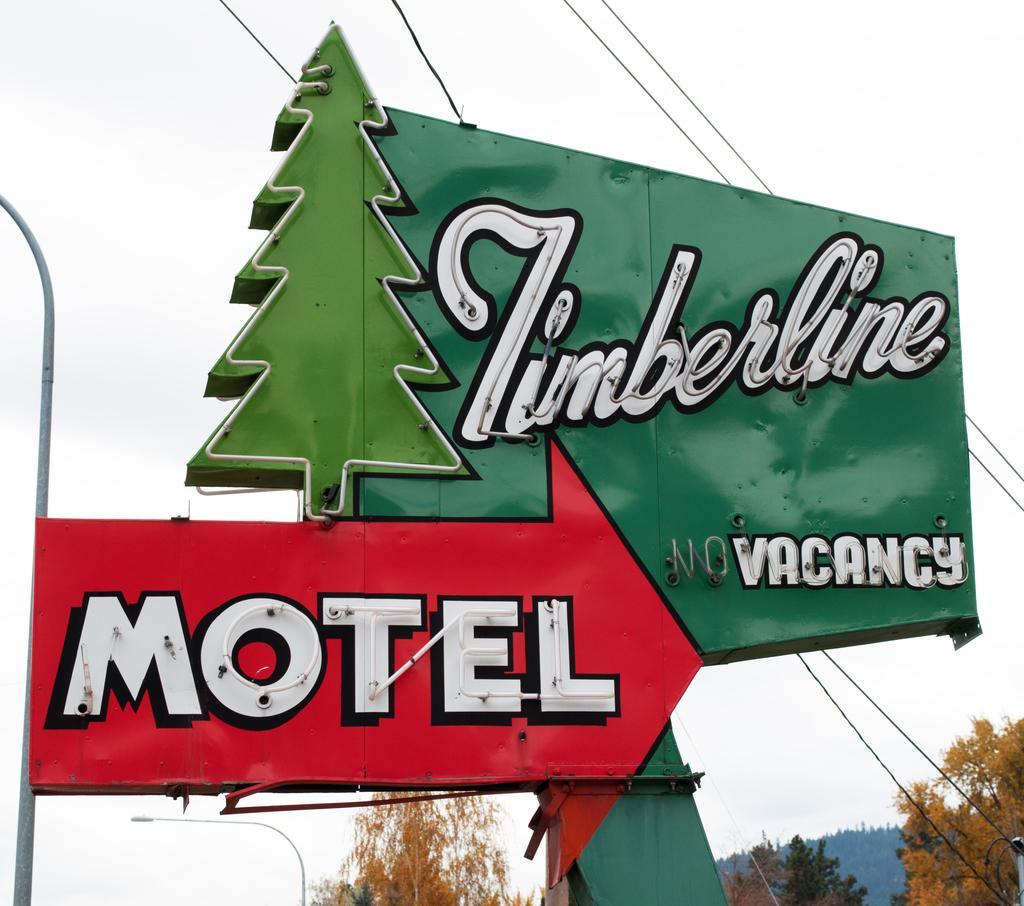Could you give a brief overview of what you see in this image? In this picture, we see a red color board with text written as "MOTEL". Behind that, we see a green color board with some text written on it. At the bottom of the picture, there are trees. At the top of the picture, we see the sky and the wires. 